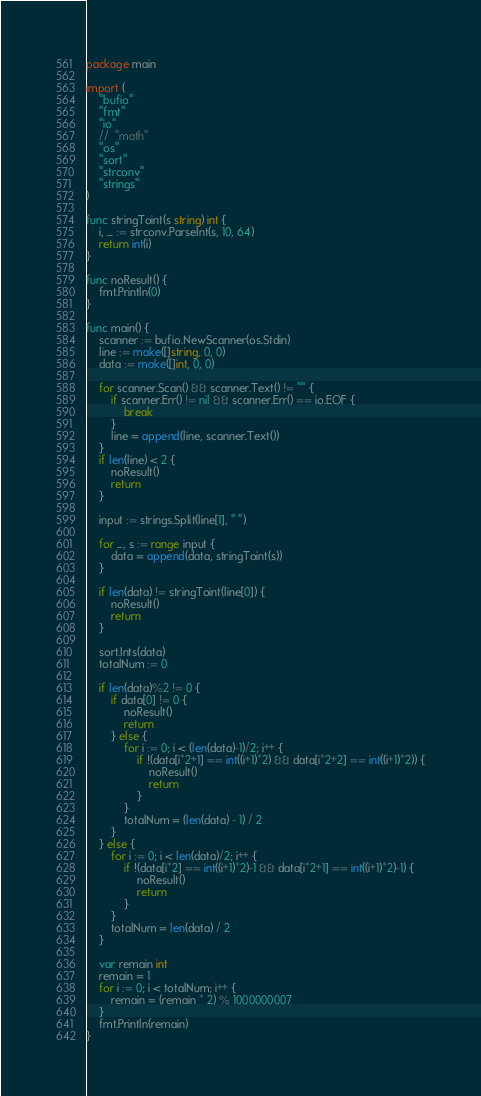Convert code to text. <code><loc_0><loc_0><loc_500><loc_500><_Go_>package main

import (
	"bufio"
	"fmt"
	"io"
	//	"math"
	"os"
	"sort"
	"strconv"
	"strings"
)

func stringToint(s string) int {
	i, _ := strconv.ParseInt(s, 10, 64)
	return int(i)
}

func noResult() {
	fmt.Println(0)
}

func main() {
	scanner := bufio.NewScanner(os.Stdin)
	line := make([]string, 0, 0)
	data := make([]int, 0, 0)

	for scanner.Scan() && scanner.Text() != "" {
		if scanner.Err() != nil && scanner.Err() == io.EOF {
			break
		}
		line = append(line, scanner.Text())
	}
	if len(line) < 2 {
		noResult()
		return
	}

	input := strings.Split(line[1], " ")

	for _, s := range input {
		data = append(data, stringToint(s))
	}

	if len(data) != stringToint(line[0]) {
		noResult()
		return
	}

	sort.Ints(data)
	totalNum := 0

	if len(data)%2 != 0 {
		if data[0] != 0 {
			noResult()
			return
		} else {
			for i := 0; i < (len(data)-1)/2; i++ {
				if !(data[i*2+1] == int((i+1)*2) && data[i*2+2] == int((i+1)*2)) {
					noResult()
					return
				}
			}
			totalNum = (len(data) - 1) / 2
		}
	} else {
		for i := 0; i < len(data)/2; i++ {
			if !(data[i*2] == int((i+1)*2)-1 && data[i*2+1] == int((i+1)*2)-1) {
				noResult()
				return
			}
		}
		totalNum = len(data) / 2
	}

	var remain int
	remain = 1
	for i := 0; i < totalNum; i++ {
		remain = (remain * 2) % 1000000007
	}
	fmt.Println(remain)
}</code> 